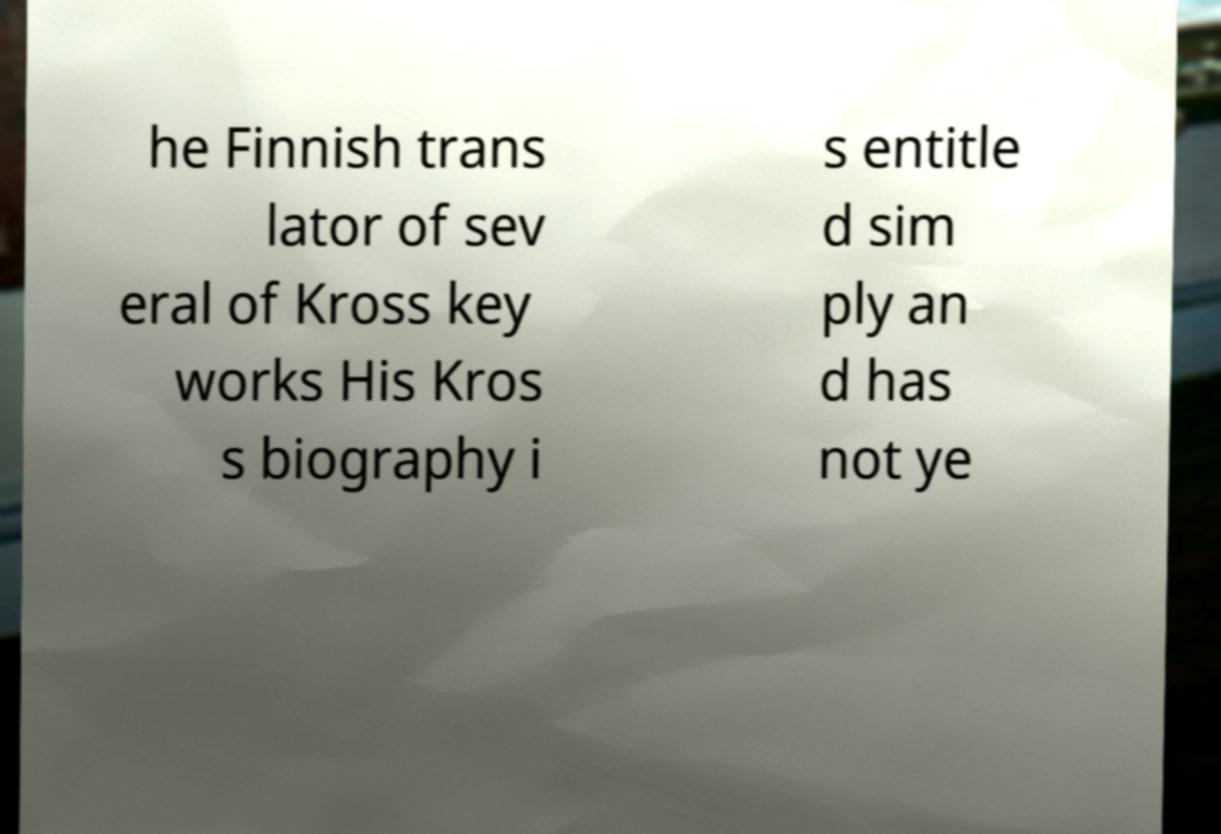What messages or text are displayed in this image? I need them in a readable, typed format. he Finnish trans lator of sev eral of Kross key works His Kros s biography i s entitle d sim ply an d has not ye 